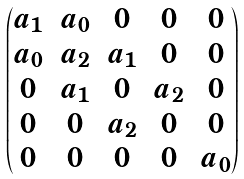<formula> <loc_0><loc_0><loc_500><loc_500>\begin{pmatrix} a _ { 1 } & a _ { 0 } & 0 & 0 & 0 \\ a _ { 0 } & a _ { 2 } & a _ { 1 } & 0 & 0 \\ 0 & a _ { 1 } & 0 & a _ { 2 } & 0 \\ 0 & 0 & a _ { 2 } & 0 & 0 \\ 0 & 0 & 0 & 0 & a _ { 0 } \end{pmatrix}</formula> 